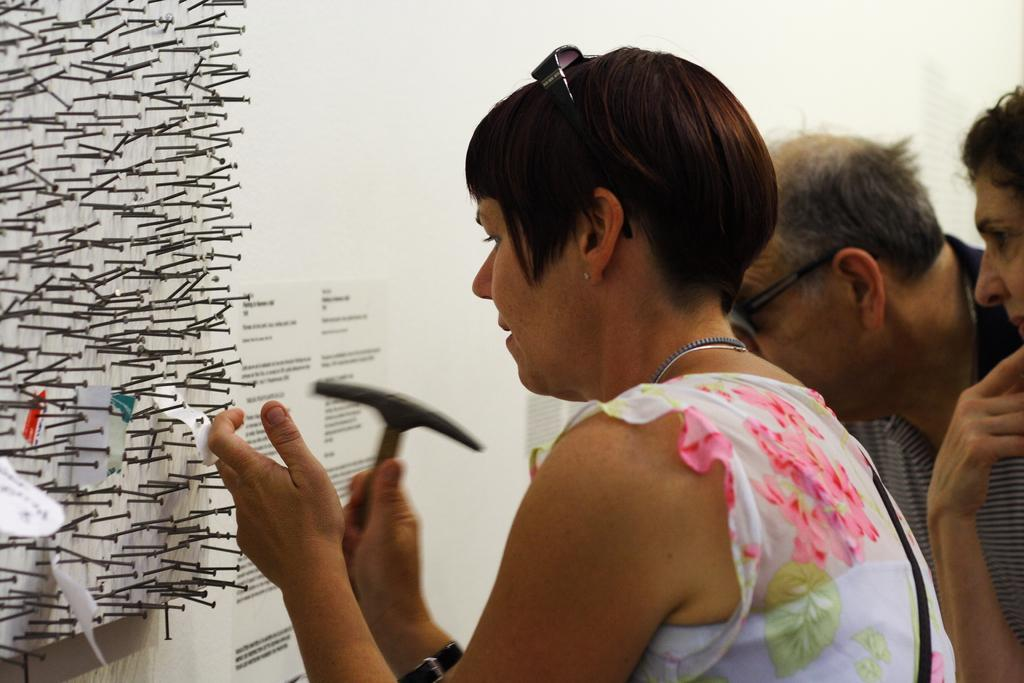How many people are in the image? There are three persons in the image. What can be seen on the left side of the image? There are metal nails on the left side of the image. What is on the wall in the image? There are papers with text on the wall in the image. What is the person in the foreground doing? The person in the foreground is holding an object. What type of apparel is the person in the image wearing? The provided facts do not mention any apparel worn by the persons in the image. --- Facts: 1. There is a car in the image. 2. The car is parked on the street. 3. There are trees on the right side of the image. 4. The sky is visible at the top of the image. Absurd Topics: dance, ocean, animal Conversation: What is the main subject of the image? The main subject of the image is a car. Where is the car located in the image? The car is parked on the street. What type of vegetation is on the right side of the image? There are trees on the right side of the image. What is visible at the top of the image? The sky is visible at the top of the image. Reasoning: Let's think step by step in order to produce the conversation. We start by identifying the main subject of the image, which is the car. Then, we describe the location and surroundings of the car, such as the street and trees. Finally, we mention the sky, which is visible at the top of the image. Each question is designed to elicit a specific detail about the image that is known from the provided facts. Absurd Question/Answer: Can you see any animals swimming in the ocean in the image? There is no ocean or animals present in the image; it features a car parked on the street. 